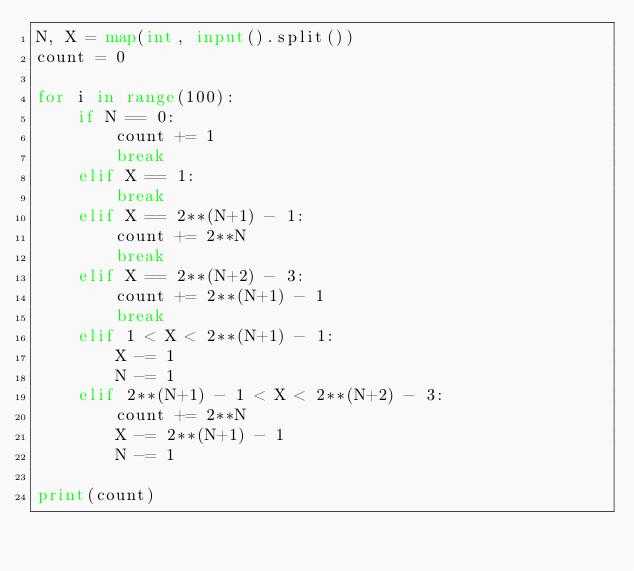<code> <loc_0><loc_0><loc_500><loc_500><_Python_>N, X = map(int, input().split())
count = 0

for i in range(100):
    if N == 0:
        count += 1
        break
    elif X == 1:
        break
    elif X == 2**(N+1) - 1:
        count += 2**N
        break
    elif X == 2**(N+2) - 3:
        count += 2**(N+1) - 1
        break
    elif 1 < X < 2**(N+1) - 1:
        X -= 1
        N -= 1
    elif 2**(N+1) - 1 < X < 2**(N+2) - 3:
        count += 2**N
        X -= 2**(N+1) - 1
        N -= 1

print(count)</code> 